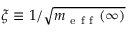<formula> <loc_0><loc_0><loc_500><loc_500>\xi \equiv 1 / \sqrt { m _ { e f f } ( \infty ) }</formula> 